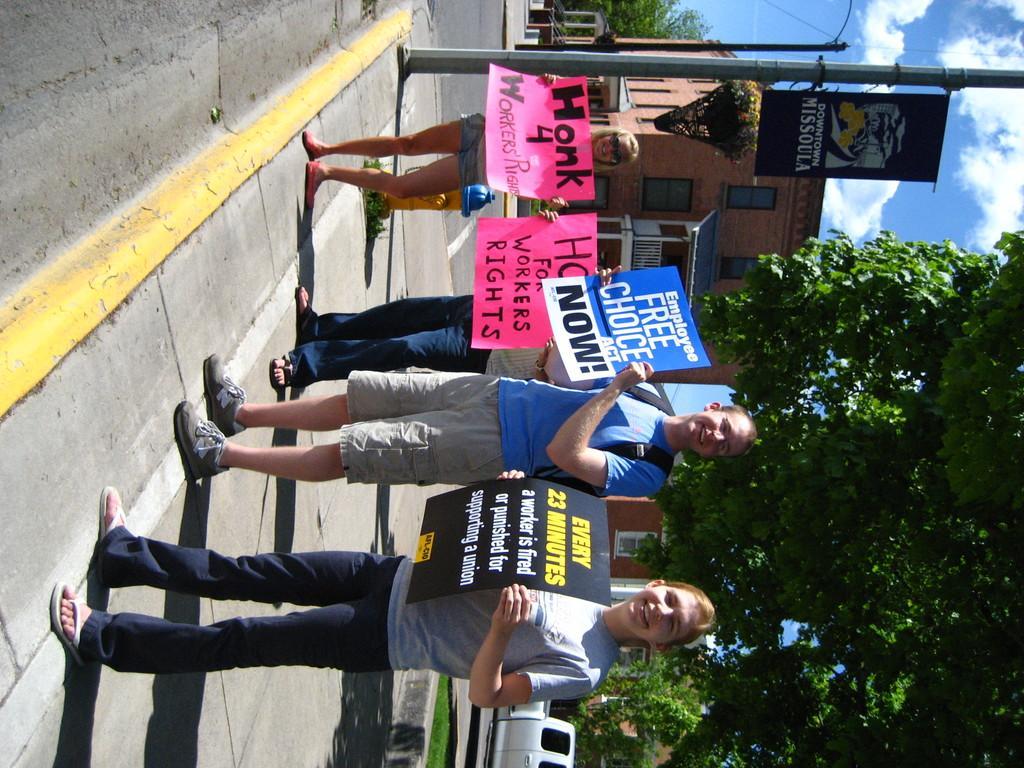In one or two sentences, can you explain what this image depicts? In this image I can see at the bottom a woman is holding the placard in her hands, she is smiling beside her a man is also doing the same, he wore blue color t-shirt, short, shoes and few other people are there. In the middle there are trees, at the top it looks like a house. 